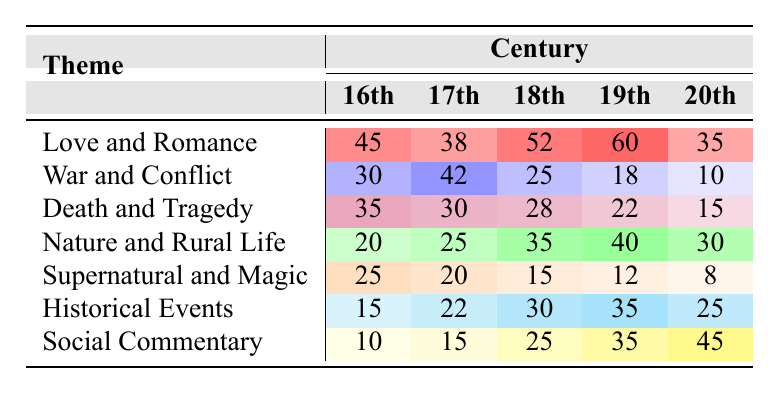What is the theme with the highest frequency in the 19th century? In the 19th century, the frequencies for each theme are as follows: Love and Romance (60), War and Conflict (18), Death and Tragedy (22), Nature and Rural Life (40), Supernatural and Magic (12), Historical Events (35), and Social Commentary (35). The theme with the highest frequency is Love and Romance at 60.
Answer: Love and Romance Which theme had the lowest frequency in the 20th century? In the 20th century, the frequencies are: Love and Romance (35), War and Conflict (10), Death and Tragedy (15), Nature and Rural Life (30), Supernatural and Magic (8), Historical Events (25), and Social Commentary (45). The lowest frequency is for Supernatural and Magic with a frequency of 8.
Answer: Supernatural and Magic How much more frequently is the theme "Death and Tragedy" represented in the 16th century compared to the 20th century? The frequency for Death and Tragedy in the 16th century is 35, and in the 20th century, it is 15. The difference is 35 - 15 = 20.
Answer: 20 What is the average frequency of the theme "Nature and Rural Life" across all centuries? The frequencies for Nature and Rural Life are 20, 25, 35, 40, and 30 in the respective centuries. The sum is 20 + 25 + 35 + 40 + 30 = 150, and there are 5 data points, so the average is 150 / 5 = 30.
Answer: 30 Is there a theme that has consistently increased in frequency from the 16th to the 20th century? Analyzing the frequencies: Love and Romance (45, 38, 52, 60, 35) shows fluctuation, War and Conflict (30, 42, 25, 18, 10) decreases, Death and Tragedy (35, 30, 28, 22, 15) decreases, Nature and Rural Life (20, 25, 35, 40, 30) increases then decreases, Supernatural and Magic (25, 20, 15, 12, 8) decreases, Historical Events (15, 22, 30, 35, 25) increases then decreases, and Social Commentary (10, 15, 25, 35, 45) is consistently increasing. Therefore, Social Commentary is the only theme that shows consistent increase from 16th to 20th century.
Answer: Yes Which theme had the highest total frequency across all centuries? Calculating the total frequencies for each theme: Love and Romance (45 + 38 + 52 + 60 + 35 = 230), War and Conflict (30 + 42 + 25 + 18 + 10 = 125), Death and Tragedy (35 + 30 + 28 + 22 + 15 = 130), Nature and Rural Life (20 + 25 + 35 + 40 + 30 = 150), Supernatural and Magic (25 + 20 + 15 + 12 + 8 = 80), Historical Events (15 + 22 + 30 + 35 + 25 = 127), Social Commentary (10 + 15 + 25 + 35 + 45 = 130). Love and Romance has the highest total frequency at 230.
Answer: Love and Romance What is the difference in frequency between the most popular theme in the 18th century and the least popular theme in the same century? The most popular theme in the 18th century is Love and Romance with a frequency of 52, while the least popular is War and Conflict with a frequency of 25. The difference is 52 - 25 = 27.
Answer: 27 